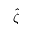<formula> <loc_0><loc_0><loc_500><loc_500>\hat { \zeta }</formula> 